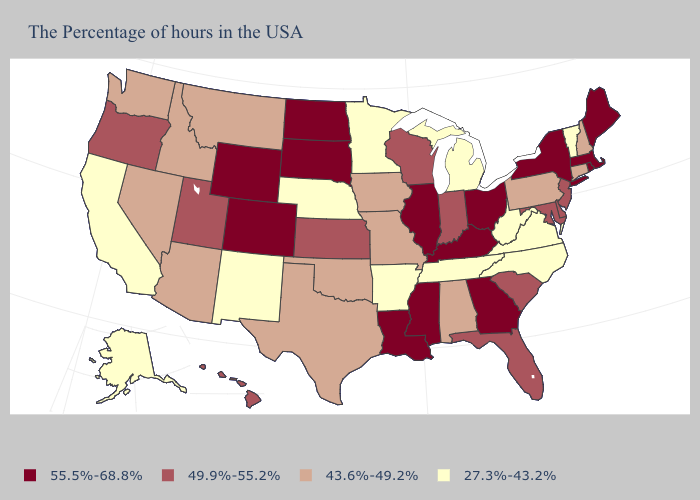How many symbols are there in the legend?
Answer briefly. 4. Among the states that border Utah , which have the highest value?
Answer briefly. Wyoming, Colorado. Which states have the lowest value in the South?
Give a very brief answer. Virginia, North Carolina, West Virginia, Tennessee, Arkansas. Name the states that have a value in the range 27.3%-43.2%?
Answer briefly. Vermont, Virginia, North Carolina, West Virginia, Michigan, Tennessee, Arkansas, Minnesota, Nebraska, New Mexico, California, Alaska. What is the value of South Carolina?
Answer briefly. 49.9%-55.2%. What is the value of Ohio?
Write a very short answer. 55.5%-68.8%. Name the states that have a value in the range 43.6%-49.2%?
Give a very brief answer. New Hampshire, Connecticut, Pennsylvania, Alabama, Missouri, Iowa, Oklahoma, Texas, Montana, Arizona, Idaho, Nevada, Washington. Name the states that have a value in the range 27.3%-43.2%?
Be succinct. Vermont, Virginia, North Carolina, West Virginia, Michigan, Tennessee, Arkansas, Minnesota, Nebraska, New Mexico, California, Alaska. Is the legend a continuous bar?
Short answer required. No. What is the value of Rhode Island?
Give a very brief answer. 55.5%-68.8%. Does Connecticut have the lowest value in the Northeast?
Answer briefly. No. Does Louisiana have the highest value in the USA?
Quick response, please. Yes. What is the highest value in states that border Washington?
Write a very short answer. 49.9%-55.2%. Name the states that have a value in the range 27.3%-43.2%?
Concise answer only. Vermont, Virginia, North Carolina, West Virginia, Michigan, Tennessee, Arkansas, Minnesota, Nebraska, New Mexico, California, Alaska. Does New York have a lower value than Oklahoma?
Give a very brief answer. No. 